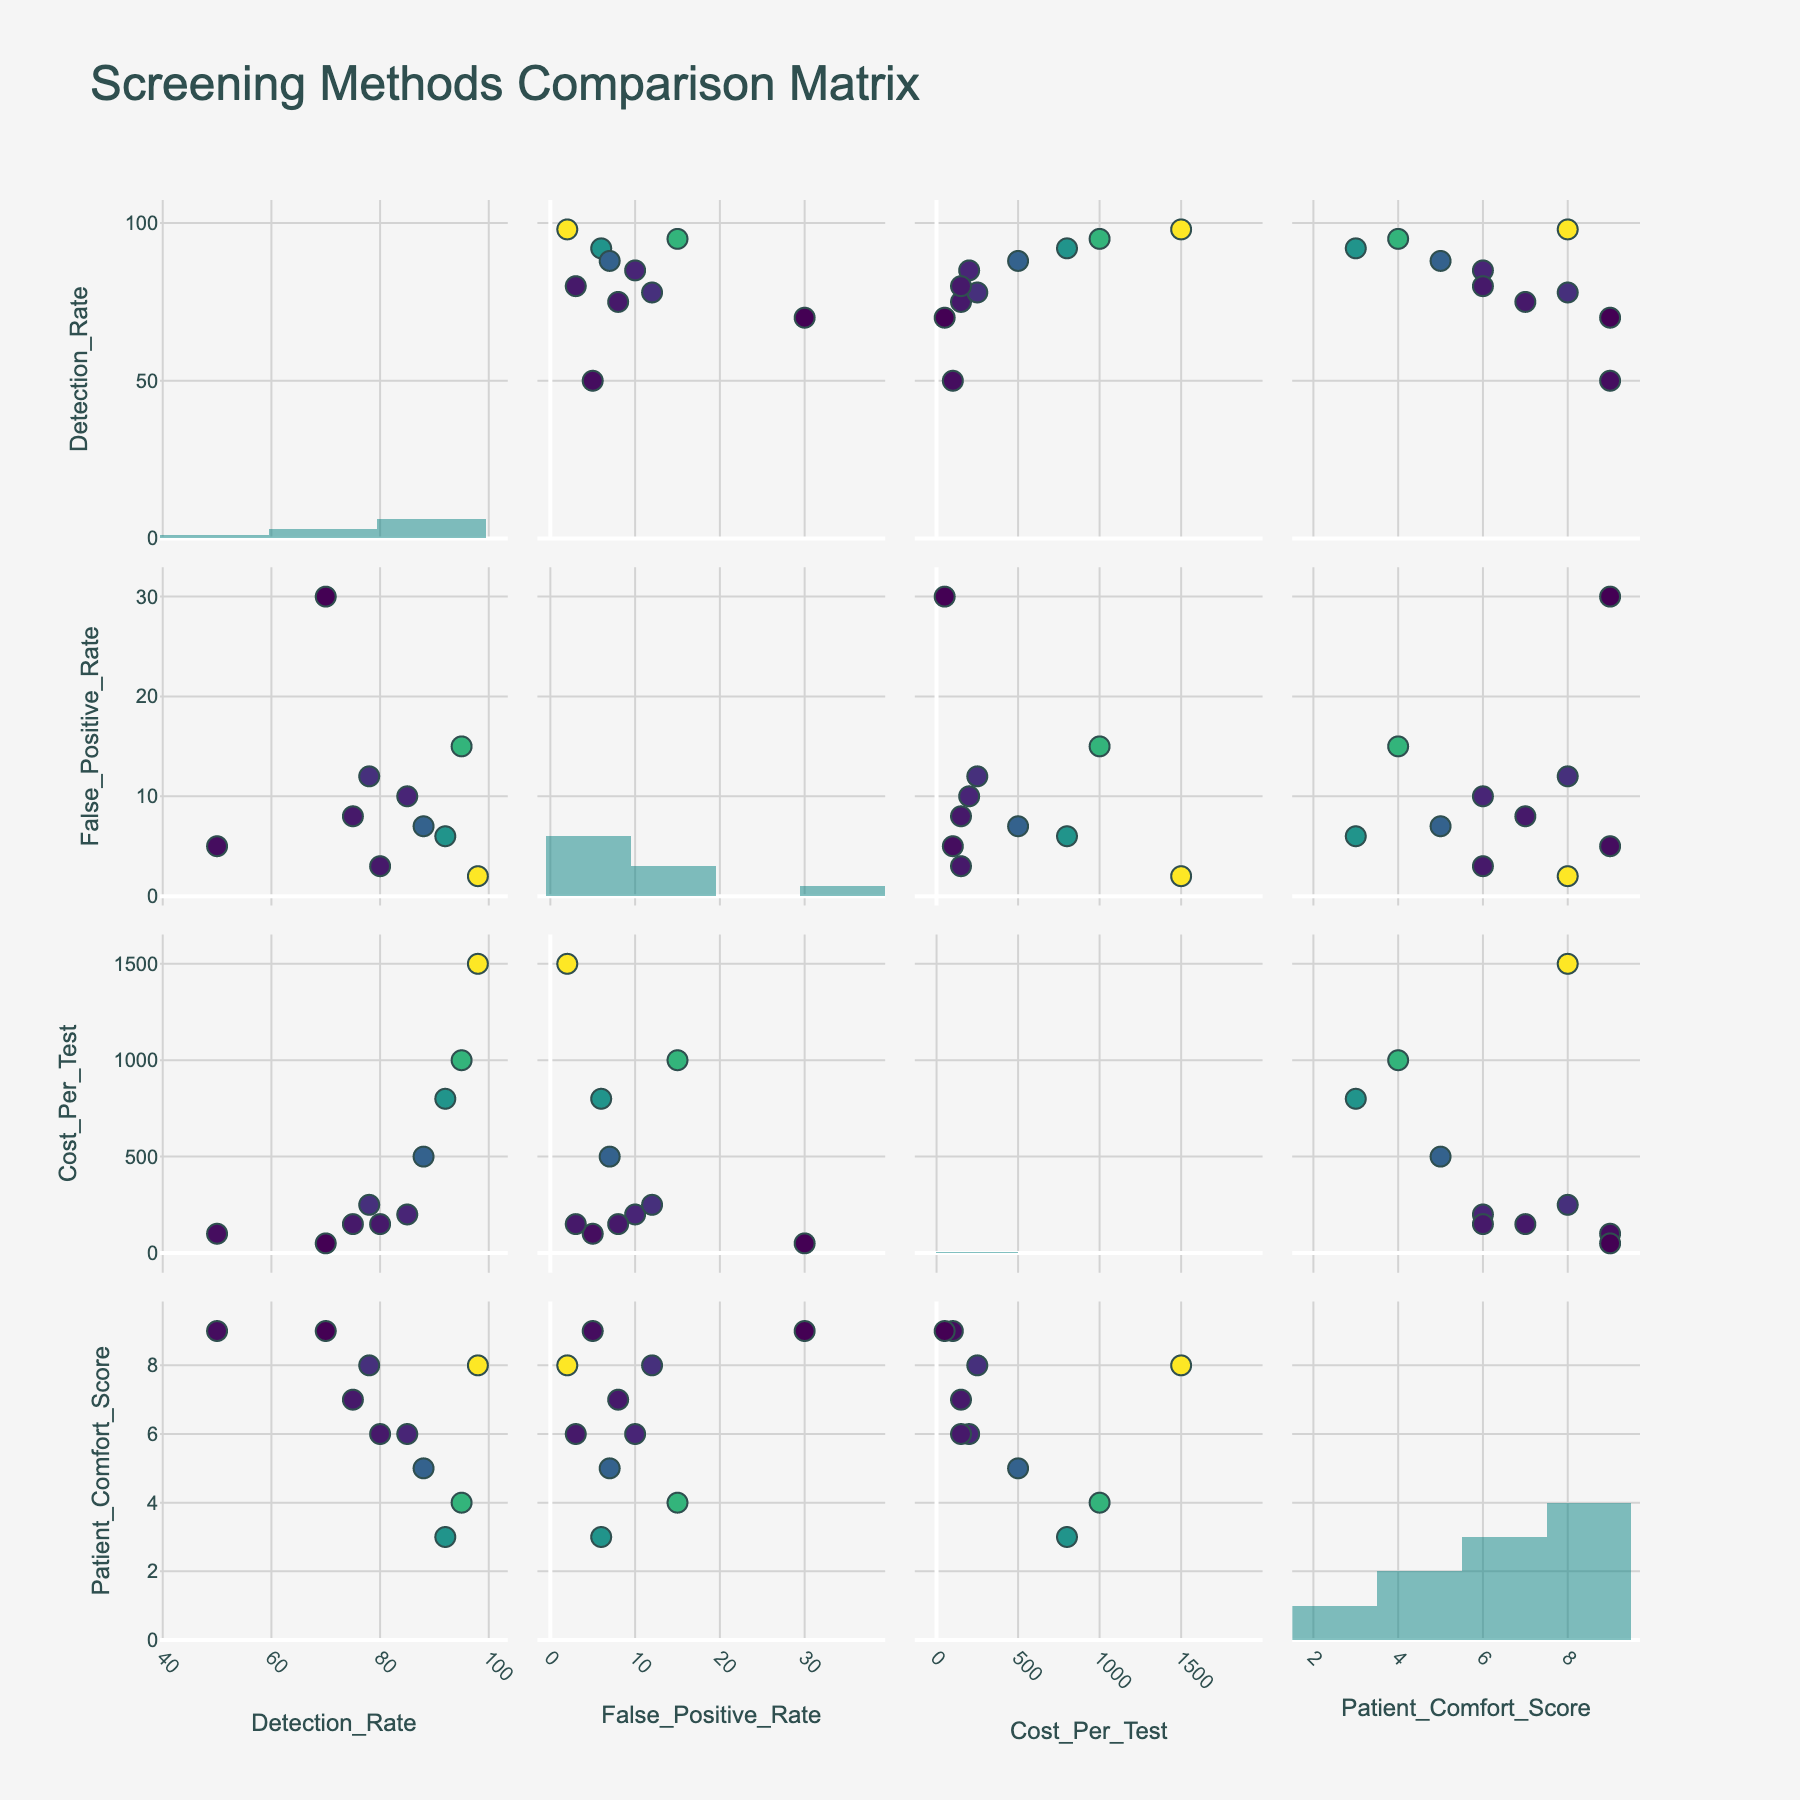what is the title of the figure? The title of the figure is located at the top of the plot, generally in a larger font size and bold. From the provided data, it is clear that the title mentions the distribution of stress factors.
Answer: Distribution of Stress Factors Affecting First-Year Medical Students Which category has the highest percentage for a single stress factor? Each category has its stress factors shown in separate pie charts. The 'Academic' category has 'Exam Preparation' with a percentage of 35%, which is the highest among all individual factors in any category.
Answer: Academic What percentage of stress is attributed to sleep deprivation? Look at the 'Personal' category pie chart and examine the segment for 'Sleep Deprivation'. The corresponding percentage is stated directly on the pie chart.
Answer: 10% How does the percentage of 'Faculty Expectations' compare between the 'Institutional' and 'Personal' categories? The 'Faculty Expectations' stress factor appears only under the 'Institutional' category with 8% and has no direct pairing with the 'Personal' category. Hence, comparing it is direct.
Answer: Exists only in 'Institutional' with 8% What is the combined percentage of 'Financial Stress' and 'Social Life Balance' stress factors? Both these factors fall under the 'Personal' category. Adding their percentages together (Financial Stress 7% + Social Life Balance 8%) gives the total.
Answer: 15% Which category has the smallest individual stress factor percentage and what is it? Look at all the pie charts for the smallest segment. The 'Health' category has 'Burnout Prevention' with the smallest individual stress factor percentage of 5%.
Answer: Health, Burnout Prevention, 5% Compare the stress percentages of 'Exam Preparation' and 'Coursework Load'. Both factors are under the 'Academic' category. 'Exam Preparation' accounts for 35% and 'Coursework Load' for 25%. Comparing these two, 'Exam Preparation' has a larger percentage.
Answer: 'Exam Preparation' is larger by 10% What is the average percentage of stress for the factors under the 'Health' category? The 'Health' category includes 'Mental Health Concerns' (9%), 'Physical Health Maintenance' (6%), and 'Burnout Prevention' (5%). Calculate the average by summing these and dividing by the number of factors: (9 + 6 + 5) / 3 = 20/3.
Answer: Approximately 6.67% Within the 'Institutional' category, which stress factor affects students the most? Look at the pie chart for the 'Institutional' category and identify the segment with the largest percentage. 'Adapting to Medical School Culture' has the highest percentage with 12%.
Answer: Adapting to Medical School Culture What is the total percentage for 'Clinical Skills Practice' and 'Time Management'? 'Clinical Skills Practice' is under the 'Academic' category with 15% and 'Time Management' is under the 'Institutional' category with 10%. Summing these two gives the total percentage: 15 + 10.
Answer: 25% 